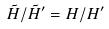<formula> <loc_0><loc_0><loc_500><loc_500>\tilde { H } / \tilde { H } ^ { \prime } = H / H ^ { \prime }</formula> 